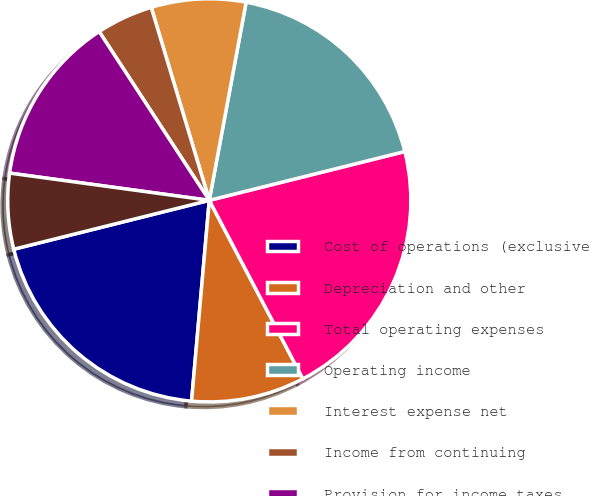Convert chart. <chart><loc_0><loc_0><loc_500><loc_500><pie_chart><fcel>Cost of operations (exclusive<fcel>Depreciation and other<fcel>Total operating expenses<fcel>Operating income<fcel>Interest expense net<fcel>Income from continuing<fcel>Provision for income taxes<fcel>Loss from discontinued<nl><fcel>19.7%<fcel>9.09%<fcel>21.21%<fcel>18.18%<fcel>7.58%<fcel>4.55%<fcel>13.64%<fcel>6.06%<nl></chart> 